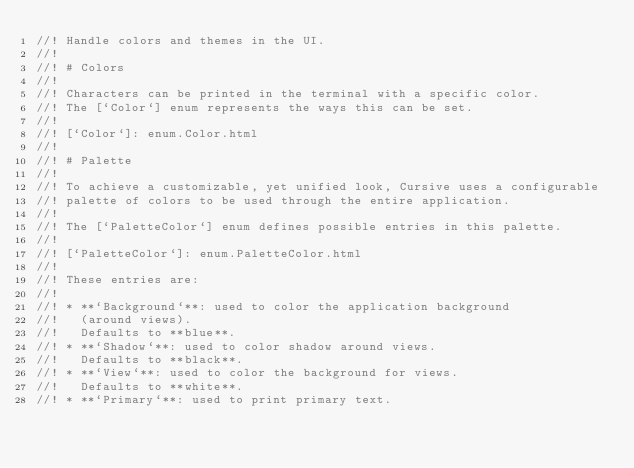<code> <loc_0><loc_0><loc_500><loc_500><_Rust_>//! Handle colors and themes in the UI.
//!
//! # Colors
//!
//! Characters can be printed in the terminal with a specific color.
//! The [`Color`] enum represents the ways this can be set.
//!
//! [`Color`]: enum.Color.html
//!
//! # Palette
//!
//! To achieve a customizable, yet unified look, Cursive uses a configurable
//! palette of colors to be used through the entire application.
//!
//! The [`PaletteColor`] enum defines possible entries in this palette.
//!
//! [`PaletteColor`]: enum.PaletteColor.html
//!
//! These entries are:
//!
//! * **`Background`**: used to color the application background
//!   (around views).
//!   Defaults to **blue**.
//! * **`Shadow`**: used to color shadow around views.
//!   Defaults to **black**.
//! * **`View`**: used to color the background for views.
//!   Defaults to **white**.
//! * **`Primary`**: used to print primary text.</code> 